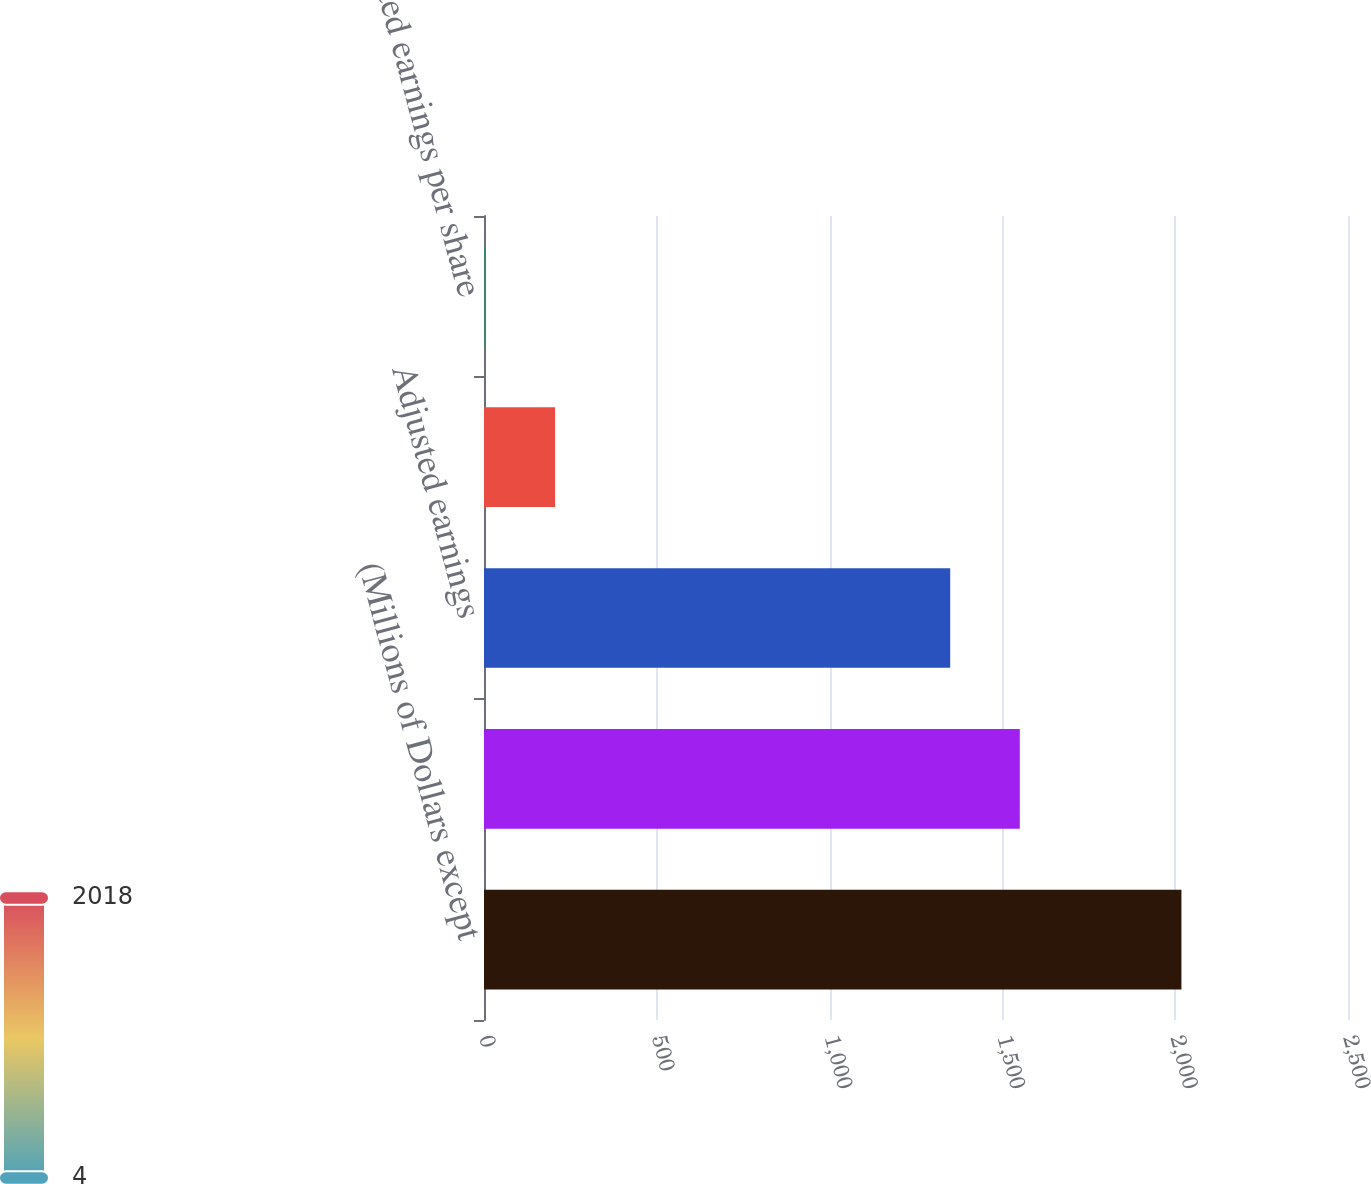Convert chart to OTSL. <chart><loc_0><loc_0><loc_500><loc_500><bar_chart><fcel>(Millions of Dollars except<fcel>Reported net income for common<fcel>Adjusted earnings<fcel>Reported earnings per share -<fcel>Adjusted earnings per share<nl><fcel>2018<fcel>1550.37<fcel>1349<fcel>205.7<fcel>4.33<nl></chart> 